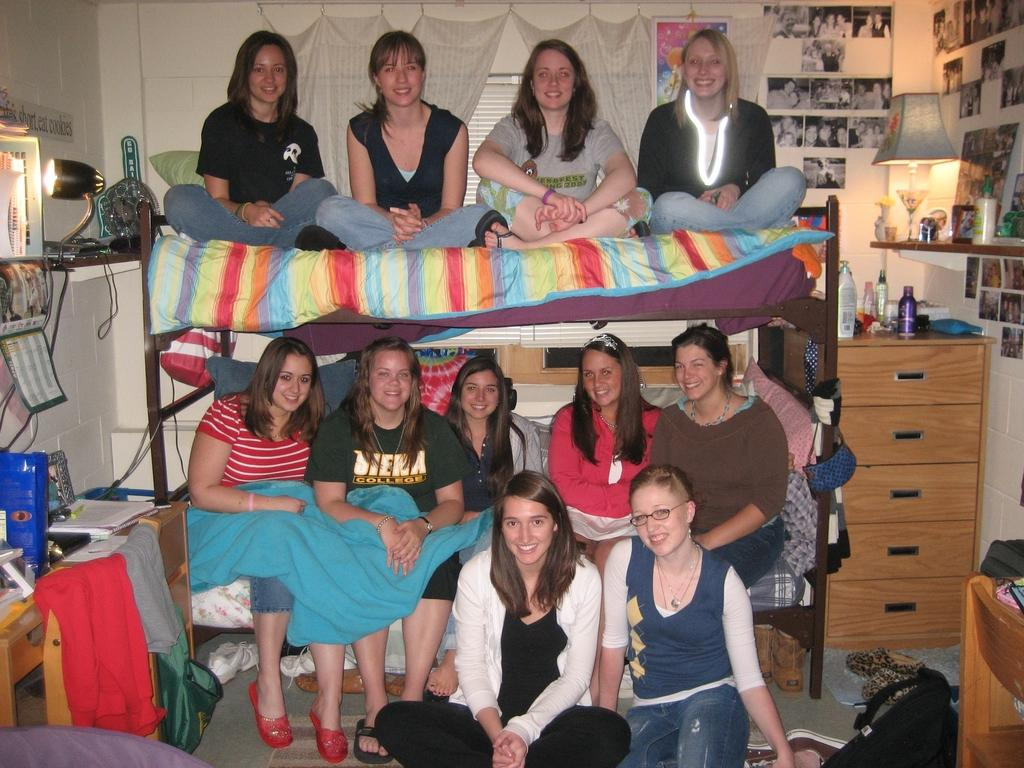How many women are in the image? There is a group of women in the image. What are the women doing in the image? Some women are sitting on the bed, and two women are sitting on the floor. What can be seen in the background of the image? There is a cupboard, a chair, a lamp, and curtains in the background of the image. What news is being discussed by the crowd in the image? There is no crowd present in the image, and therefore no discussion of news can be observed. How many towns are visible in the image? There are no towns visible in the image. 